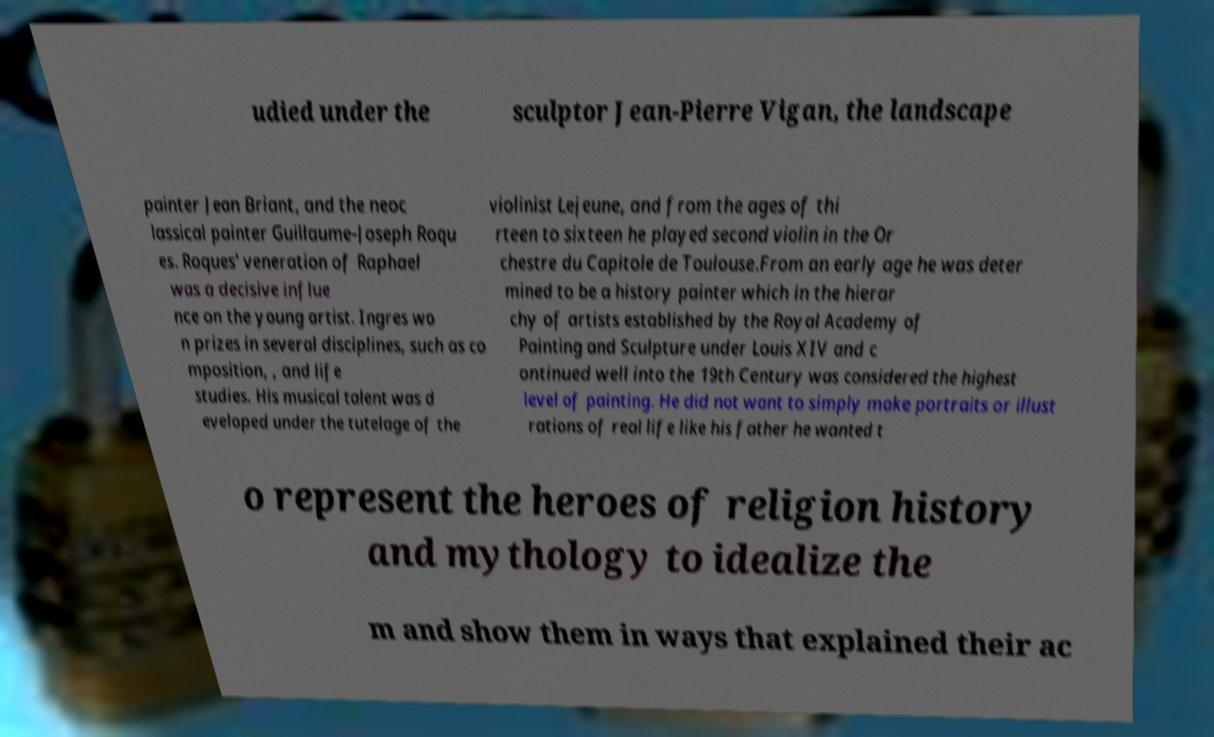There's text embedded in this image that I need extracted. Can you transcribe it verbatim? udied under the sculptor Jean-Pierre Vigan, the landscape painter Jean Briant, and the neoc lassical painter Guillaume-Joseph Roqu es. Roques' veneration of Raphael was a decisive influe nce on the young artist. Ingres wo n prizes in several disciplines, such as co mposition, , and life studies. His musical talent was d eveloped under the tutelage of the violinist Lejeune, and from the ages of thi rteen to sixteen he played second violin in the Or chestre du Capitole de Toulouse.From an early age he was deter mined to be a history painter which in the hierar chy of artists established by the Royal Academy of Painting and Sculpture under Louis XIV and c ontinued well into the 19th Century was considered the highest level of painting. He did not want to simply make portraits or illust rations of real life like his father he wanted t o represent the heroes of religion history and mythology to idealize the m and show them in ways that explained their ac 